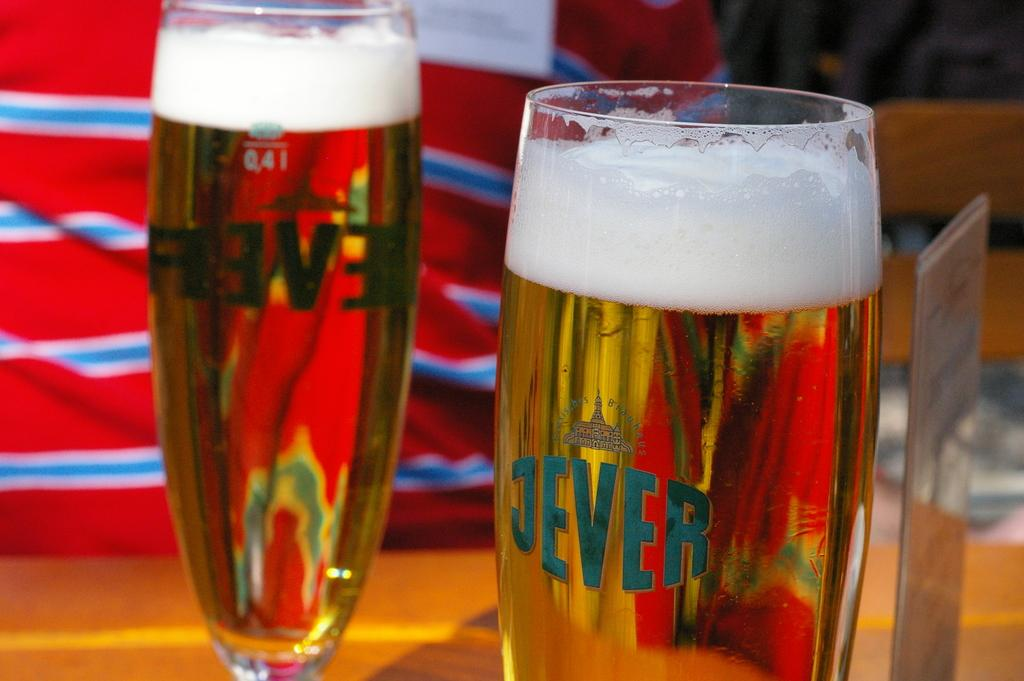<image>
Relay a brief, clear account of the picture shown. two champagne with Jever on them are full and on the table 